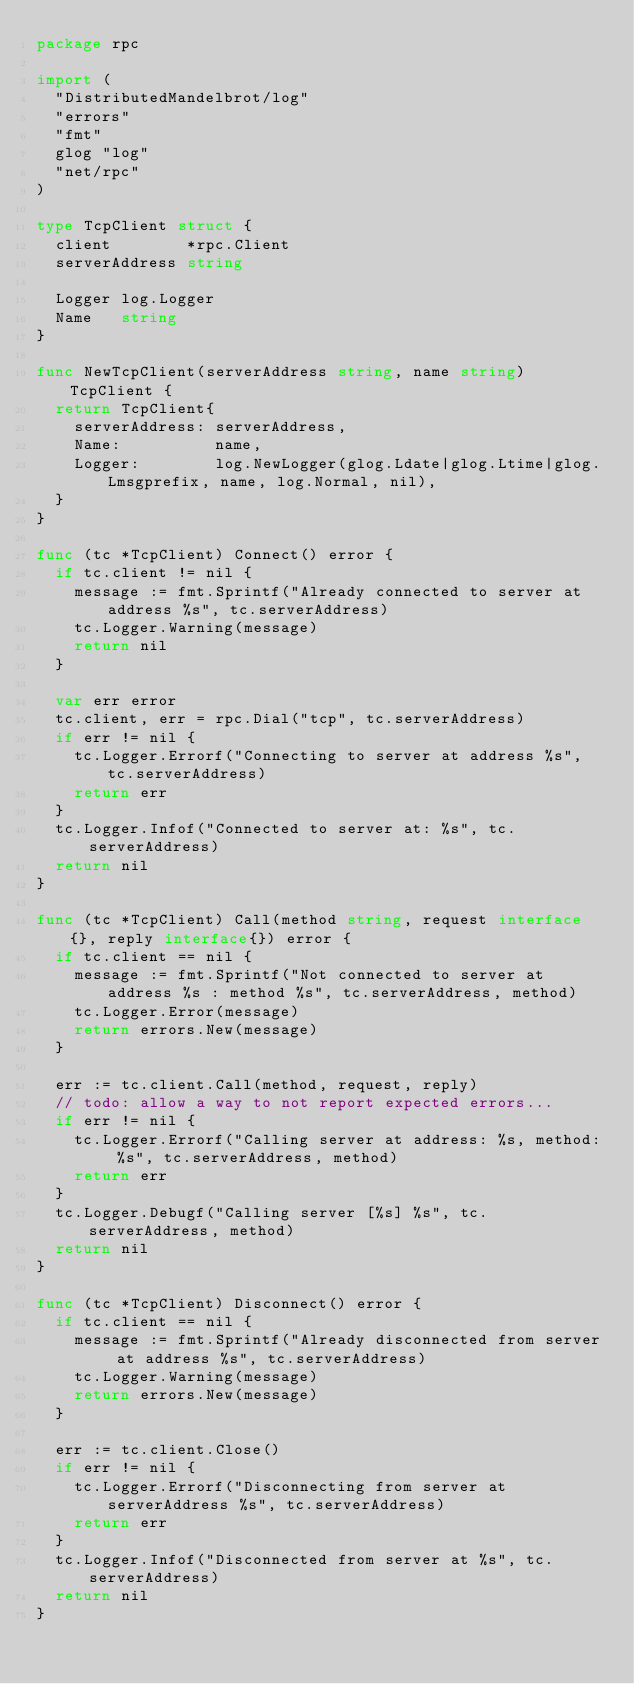Convert code to text. <code><loc_0><loc_0><loc_500><loc_500><_Go_>package rpc

import (
	"DistributedMandelbrot/log"
	"errors"
	"fmt"
	glog "log"
	"net/rpc"
)

type TcpClient struct {
	client        *rpc.Client
	serverAddress string

	Logger log.Logger
	Name   string
}

func NewTcpClient(serverAddress string, name string) TcpClient {
	return TcpClient{
		serverAddress: serverAddress,
		Name:          name,
		Logger:        log.NewLogger(glog.Ldate|glog.Ltime|glog.Lmsgprefix, name, log.Normal, nil),
	}
}

func (tc *TcpClient) Connect() error {
	if tc.client != nil {
		message := fmt.Sprintf("Already connected to server at address %s", tc.serverAddress)
		tc.Logger.Warning(message)
		return nil
	}

	var err error
	tc.client, err = rpc.Dial("tcp", tc.serverAddress)
	if err != nil {
		tc.Logger.Errorf("Connecting to server at address %s", tc.serverAddress)
		return err
	}
	tc.Logger.Infof("Connected to server at: %s", tc.serverAddress)
	return nil
}

func (tc *TcpClient) Call(method string, request interface{}, reply interface{}) error {
	if tc.client == nil {
		message := fmt.Sprintf("Not connected to server at address %s : method %s", tc.serverAddress, method)
		tc.Logger.Error(message)
		return errors.New(message)
	}

	err := tc.client.Call(method, request, reply)
	// todo: allow a way to not report expected errors...
	if err != nil {
		tc.Logger.Errorf("Calling server at address: %s, method: %s", tc.serverAddress, method)
		return err
	}
	tc.Logger.Debugf("Calling server [%s] %s", tc.serverAddress, method)
	return nil
}

func (tc *TcpClient) Disconnect() error {
	if tc.client == nil {
		message := fmt.Sprintf("Already disconnected from server at address %s", tc.serverAddress)
		tc.Logger.Warning(message)
		return errors.New(message)
	}

	err := tc.client.Close()
	if err != nil {
		tc.Logger.Errorf("Disconnecting from server at serverAddress %s", tc.serverAddress)
		return err
	}
	tc.Logger.Infof("Disconnected from server at %s", tc.serverAddress)
	return nil
}
</code> 